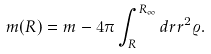Convert formula to latex. <formula><loc_0><loc_0><loc_500><loc_500>m ( R ) = m - 4 \pi \int _ { R } ^ { R _ { \infty } } d r r ^ { 2 } \varrho .</formula> 